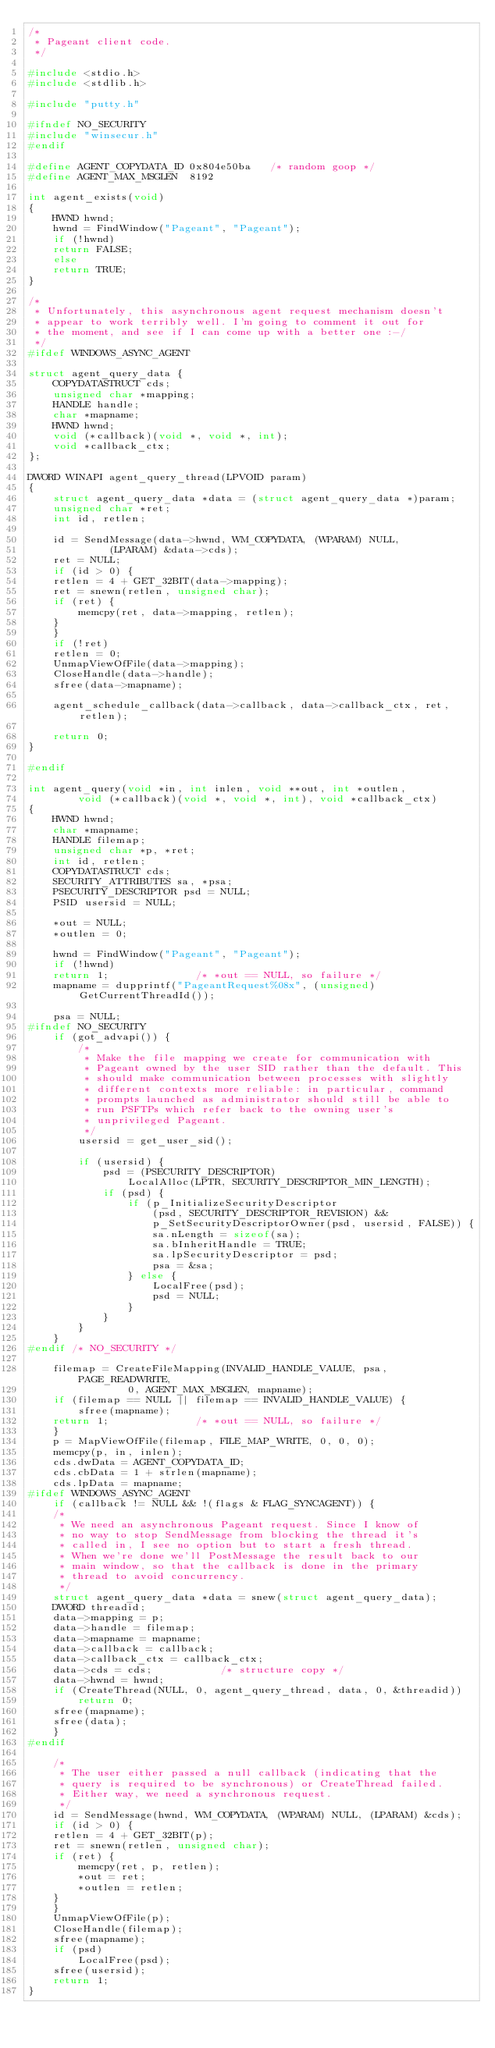<code> <loc_0><loc_0><loc_500><loc_500><_C_>/*
 * Pageant client code.
 */

#include <stdio.h>
#include <stdlib.h>

#include "putty.h"

#ifndef NO_SECURITY
#include "winsecur.h"
#endif

#define AGENT_COPYDATA_ID 0x804e50ba   /* random goop */
#define AGENT_MAX_MSGLEN  8192

int agent_exists(void)
{
    HWND hwnd;
    hwnd = FindWindow("Pageant", "Pageant");
    if (!hwnd)
	return FALSE;
    else
	return TRUE;
}

/*
 * Unfortunately, this asynchronous agent request mechanism doesn't
 * appear to work terribly well. I'm going to comment it out for
 * the moment, and see if I can come up with a better one :-/
 */
#ifdef WINDOWS_ASYNC_AGENT

struct agent_query_data {
    COPYDATASTRUCT cds;
    unsigned char *mapping;
    HANDLE handle;
    char *mapname;
    HWND hwnd;
    void (*callback)(void *, void *, int);
    void *callback_ctx;
};

DWORD WINAPI agent_query_thread(LPVOID param)
{
    struct agent_query_data *data = (struct agent_query_data *)param;
    unsigned char *ret;
    int id, retlen;

    id = SendMessage(data->hwnd, WM_COPYDATA, (WPARAM) NULL,
		     (LPARAM) &data->cds);
    ret = NULL;
    if (id > 0) {
	retlen = 4 + GET_32BIT(data->mapping);
	ret = snewn(retlen, unsigned char);
	if (ret) {
	    memcpy(ret, data->mapping, retlen);
	}
    }
    if (!ret)
	retlen = 0;
    UnmapViewOfFile(data->mapping);
    CloseHandle(data->handle);
    sfree(data->mapname);

    agent_schedule_callback(data->callback, data->callback_ctx, ret, retlen);

    return 0;
}

#endif

int agent_query(void *in, int inlen, void **out, int *outlen,
		void (*callback)(void *, void *, int), void *callback_ctx)
{
    HWND hwnd;
    char *mapname;
    HANDLE filemap;
    unsigned char *p, *ret;
    int id, retlen;
    COPYDATASTRUCT cds;
    SECURITY_ATTRIBUTES sa, *psa;
    PSECURITY_DESCRIPTOR psd = NULL;
    PSID usersid = NULL;

    *out = NULL;
    *outlen = 0;

    hwnd = FindWindow("Pageant", "Pageant");
    if (!hwnd)
	return 1;		       /* *out == NULL, so failure */
    mapname = dupprintf("PageantRequest%08x", (unsigned)GetCurrentThreadId());

    psa = NULL;
#ifndef NO_SECURITY
    if (got_advapi()) {
        /*
         * Make the file mapping we create for communication with
         * Pageant owned by the user SID rather than the default. This
         * should make communication between processes with slightly
         * different contexts more reliable: in particular, command
         * prompts launched as administrator should still be able to
         * run PSFTPs which refer back to the owning user's
         * unprivileged Pageant.
         */
        usersid = get_user_sid();

        if (usersid) {
            psd = (PSECURITY_DESCRIPTOR)
                LocalAlloc(LPTR, SECURITY_DESCRIPTOR_MIN_LENGTH);
            if (psd) {
                if (p_InitializeSecurityDescriptor
                    (psd, SECURITY_DESCRIPTOR_REVISION) &&
                    p_SetSecurityDescriptorOwner(psd, usersid, FALSE)) {
                    sa.nLength = sizeof(sa);
                    sa.bInheritHandle = TRUE;
                    sa.lpSecurityDescriptor = psd;
                    psa = &sa;
                } else {
                    LocalFree(psd);
                    psd = NULL;
                }
            }
        }
    }
#endif /* NO_SECURITY */

    filemap = CreateFileMapping(INVALID_HANDLE_VALUE, psa, PAGE_READWRITE,
				0, AGENT_MAX_MSGLEN, mapname);
    if (filemap == NULL || filemap == INVALID_HANDLE_VALUE) {
        sfree(mapname);
	return 1;		       /* *out == NULL, so failure */
    }
    p = MapViewOfFile(filemap, FILE_MAP_WRITE, 0, 0, 0);
    memcpy(p, in, inlen);
    cds.dwData = AGENT_COPYDATA_ID;
    cds.cbData = 1 + strlen(mapname);
    cds.lpData = mapname;
#ifdef WINDOWS_ASYNC_AGENT
    if (callback != NULL && !(flags & FLAG_SYNCAGENT)) {
	/*
	 * We need an asynchronous Pageant request. Since I know of
	 * no way to stop SendMessage from blocking the thread it's
	 * called in, I see no option but to start a fresh thread.
	 * When we're done we'll PostMessage the result back to our
	 * main window, so that the callback is done in the primary
	 * thread to avoid concurrency.
	 */
	struct agent_query_data *data = snew(struct agent_query_data);
	DWORD threadid;
	data->mapping = p;
	data->handle = filemap;
	data->mapname = mapname;
	data->callback = callback;
	data->callback_ctx = callback_ctx;
	data->cds = cds;	       /* structure copy */
	data->hwnd = hwnd;
	if (CreateThread(NULL, 0, agent_query_thread, data, 0, &threadid))
	    return 0;
	sfree(mapname);
	sfree(data);
    }
#endif

    /*
     * The user either passed a null callback (indicating that the
     * query is required to be synchronous) or CreateThread failed.
     * Either way, we need a synchronous request.
     */
    id = SendMessage(hwnd, WM_COPYDATA, (WPARAM) NULL, (LPARAM) &cds);
    if (id > 0) {
	retlen = 4 + GET_32BIT(p);
	ret = snewn(retlen, unsigned char);
	if (ret) {
	    memcpy(ret, p, retlen);
	    *out = ret;
	    *outlen = retlen;
	}
    }
    UnmapViewOfFile(p);
    CloseHandle(filemap);
    sfree(mapname);
    if (psd)
        LocalFree(psd);
    sfree(usersid);
    return 1;
}
</code> 